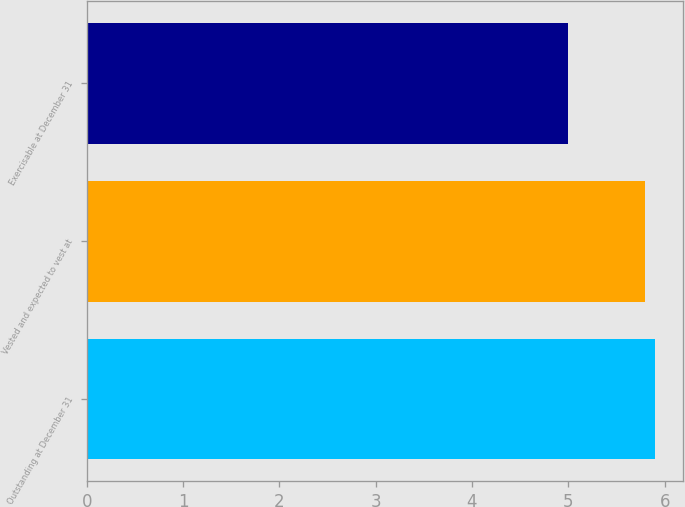Convert chart to OTSL. <chart><loc_0><loc_0><loc_500><loc_500><bar_chart><fcel>Outstanding at December 31<fcel>Vested and expected to vest at<fcel>Exercisable at December 31<nl><fcel>5.9<fcel>5.8<fcel>5<nl></chart> 